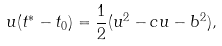Convert formula to latex. <formula><loc_0><loc_0><loc_500><loc_500>u ( t ^ { * } - t _ { 0 } ) = \frac { 1 } { 2 } ( u ^ { 2 } - c u - b ^ { 2 } ) ,</formula> 